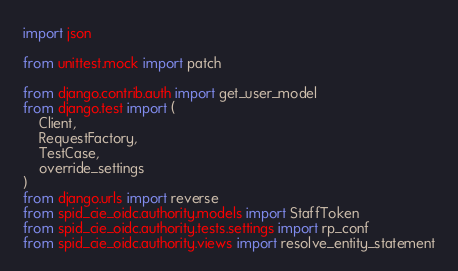<code> <loc_0><loc_0><loc_500><loc_500><_Python_>import json

from unittest.mock import patch

from django.contrib.auth import get_user_model
from django.test import (
    Client, 
    RequestFactory, 
    TestCase, 
    override_settings
)
from django.urls import reverse
from spid_cie_oidc.authority.models import StaffToken
from spid_cie_oidc.authority.tests.settings import rp_conf
from spid_cie_oidc.authority.views import resolve_entity_statement</code> 